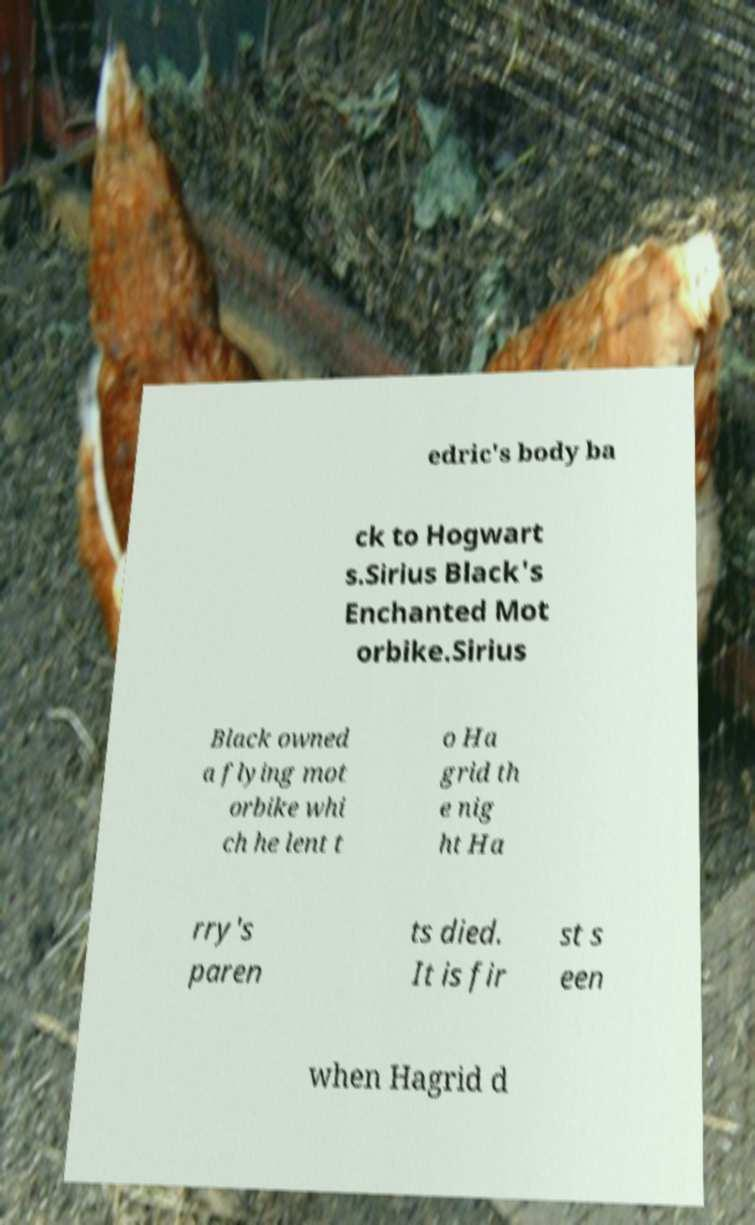Could you extract and type out the text from this image? edric's body ba ck to Hogwart s.Sirius Black's Enchanted Mot orbike.Sirius Black owned a flying mot orbike whi ch he lent t o Ha grid th e nig ht Ha rry's paren ts died. It is fir st s een when Hagrid d 